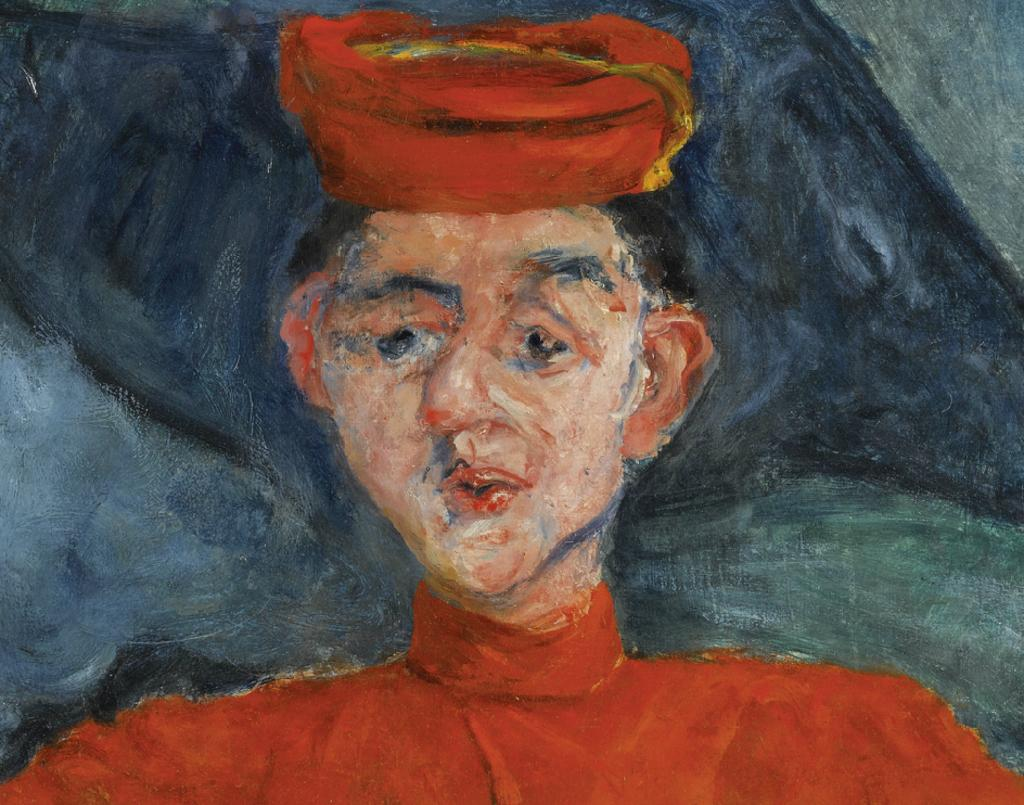What is the main subject of the image? There is a painting in the image. What is depicted in the painting? The painting depicts a person. What is the person wearing in the painting? The person is wearing clothes and a cap. What type of thunder can be heard in the background of the painting? There is no thunder present in the image, as it is a painting of a person wearing clothes and a cap. 